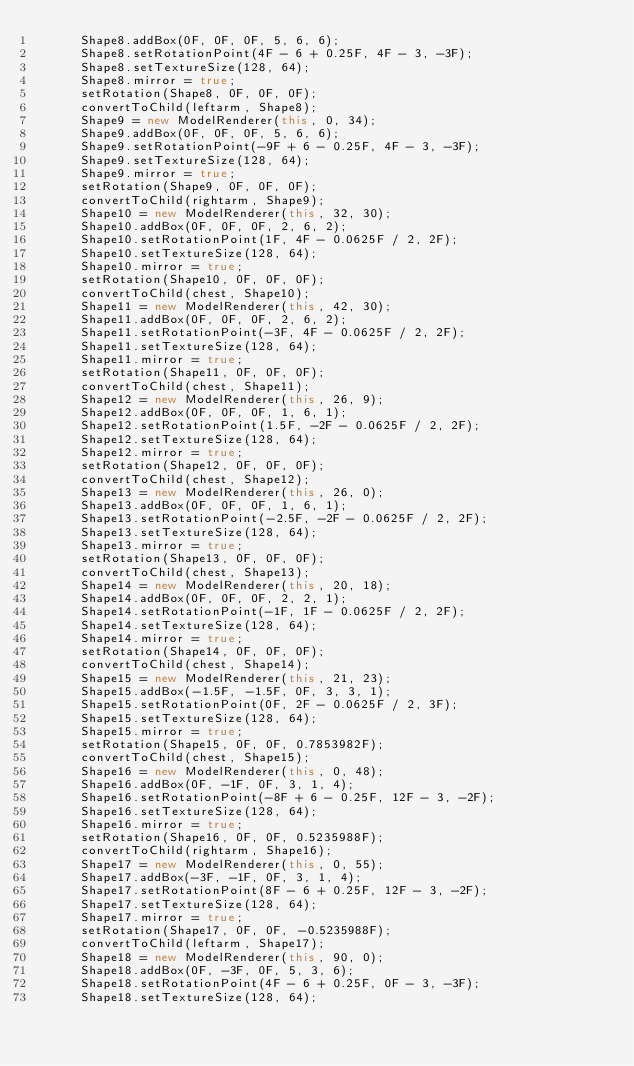Convert code to text. <code><loc_0><loc_0><loc_500><loc_500><_Java_>			Shape8.addBox(0F, 0F, 0F, 5, 6, 6);
			Shape8.setRotationPoint(4F - 6 + 0.25F, 4F - 3, -3F);
			Shape8.setTextureSize(128, 64);
			Shape8.mirror = true;
			setRotation(Shape8, 0F, 0F, 0F);
			convertToChild(leftarm, Shape8);
			Shape9 = new ModelRenderer(this, 0, 34);
			Shape9.addBox(0F, 0F, 0F, 5, 6, 6);
			Shape9.setRotationPoint(-9F + 6 - 0.25F, 4F - 3, -3F);
			Shape9.setTextureSize(128, 64);
			Shape9.mirror = true;
			setRotation(Shape9, 0F, 0F, 0F);
			convertToChild(rightarm, Shape9);
			Shape10 = new ModelRenderer(this, 32, 30);
			Shape10.addBox(0F, 0F, 0F, 2, 6, 2);
			Shape10.setRotationPoint(1F, 4F - 0.0625F / 2, 2F);
			Shape10.setTextureSize(128, 64);
			Shape10.mirror = true;
			setRotation(Shape10, 0F, 0F, 0F);
			convertToChild(chest, Shape10);
			Shape11 = new ModelRenderer(this, 42, 30);
			Shape11.addBox(0F, 0F, 0F, 2, 6, 2);
			Shape11.setRotationPoint(-3F, 4F - 0.0625F / 2, 2F);
			Shape11.setTextureSize(128, 64);
			Shape11.mirror = true;
			setRotation(Shape11, 0F, 0F, 0F);
			convertToChild(chest, Shape11);
			Shape12 = new ModelRenderer(this, 26, 9);
			Shape12.addBox(0F, 0F, 0F, 1, 6, 1);
			Shape12.setRotationPoint(1.5F, -2F - 0.0625F / 2, 2F);
			Shape12.setTextureSize(128, 64);
			Shape12.mirror = true;
			setRotation(Shape12, 0F, 0F, 0F);
			convertToChild(chest, Shape12);
			Shape13 = new ModelRenderer(this, 26, 0);
			Shape13.addBox(0F, 0F, 0F, 1, 6, 1);
			Shape13.setRotationPoint(-2.5F, -2F - 0.0625F / 2, 2F);
			Shape13.setTextureSize(128, 64);
			Shape13.mirror = true;
			setRotation(Shape13, 0F, 0F, 0F);
			convertToChild(chest, Shape13);
			Shape14 = new ModelRenderer(this, 20, 18);
			Shape14.addBox(0F, 0F, 0F, 2, 2, 1);
			Shape14.setRotationPoint(-1F, 1F - 0.0625F / 2, 2F);
			Shape14.setTextureSize(128, 64);
			Shape14.mirror = true;
			setRotation(Shape14, 0F, 0F, 0F);
			convertToChild(chest, Shape14);
			Shape15 = new ModelRenderer(this, 21, 23);
			Shape15.addBox(-1.5F, -1.5F, 0F, 3, 3, 1);
			Shape15.setRotationPoint(0F, 2F - 0.0625F / 2, 3F);
			Shape15.setTextureSize(128, 64);
			Shape15.mirror = true;
			setRotation(Shape15, 0F, 0F, 0.7853982F);
			convertToChild(chest, Shape15);
			Shape16 = new ModelRenderer(this, 0, 48);
			Shape16.addBox(0F, -1F, 0F, 3, 1, 4);
			Shape16.setRotationPoint(-8F + 6 - 0.25F, 12F - 3, -2F);
			Shape16.setTextureSize(128, 64);
			Shape16.mirror = true;
			setRotation(Shape16, 0F, 0F, 0.5235988F);
			convertToChild(rightarm, Shape16);
			Shape17 = new ModelRenderer(this, 0, 55);
			Shape17.addBox(-3F, -1F, 0F, 3, 1, 4);
			Shape17.setRotationPoint(8F - 6 + 0.25F, 12F - 3, -2F);
			Shape17.setTextureSize(128, 64);
			Shape17.mirror = true;
			setRotation(Shape17, 0F, 0F, -0.5235988F);
			convertToChild(leftarm, Shape17);
			Shape18 = new ModelRenderer(this, 90, 0);
			Shape18.addBox(0F, -3F, 0F, 5, 3, 6);
			Shape18.setRotationPoint(4F - 6 + 0.25F, 0F - 3, -3F);
			Shape18.setTextureSize(128, 64);</code> 